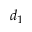Convert formula to latex. <formula><loc_0><loc_0><loc_500><loc_500>d _ { 1 }</formula> 